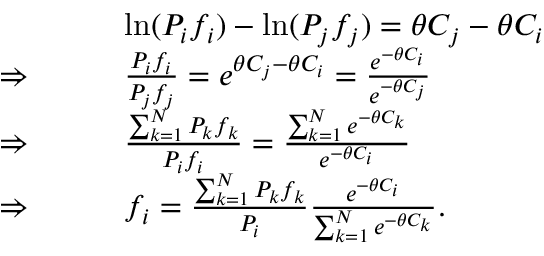<formula> <loc_0><loc_0><loc_500><loc_500>\begin{array} { r l } & { \ln ( P _ { i } f _ { i } ) - \ln ( P _ { j } f _ { j } ) = \theta C _ { j } - \theta C _ { i } } \\ { \Rightarrow \quad \ \ } & { \frac { P _ { i } f _ { i } } { P _ { j } f _ { j } } = e ^ { \theta C _ { j } - \theta C _ { i } } = \frac { e ^ { - \theta C _ { i } } } { e ^ { - \theta C _ { j } } } } \\ { \Rightarrow \quad \ \ } & { \frac { \sum _ { k = 1 } ^ { N } P _ { k } f _ { k } } { P _ { i } f _ { i } } = \frac { \sum _ { k = 1 } ^ { N } e ^ { - \theta C _ { k } } } { e ^ { - \theta C _ { i } } } } \\ { \Rightarrow \quad \ \ } & { f _ { i } = \frac { \sum _ { k = 1 } ^ { N } P _ { k } f _ { k } } { P _ { i } } \frac { e ^ { - \theta C _ { i } } } { \sum _ { k = 1 } ^ { N } e ^ { - \theta C _ { k } } } . } \end{array}</formula> 